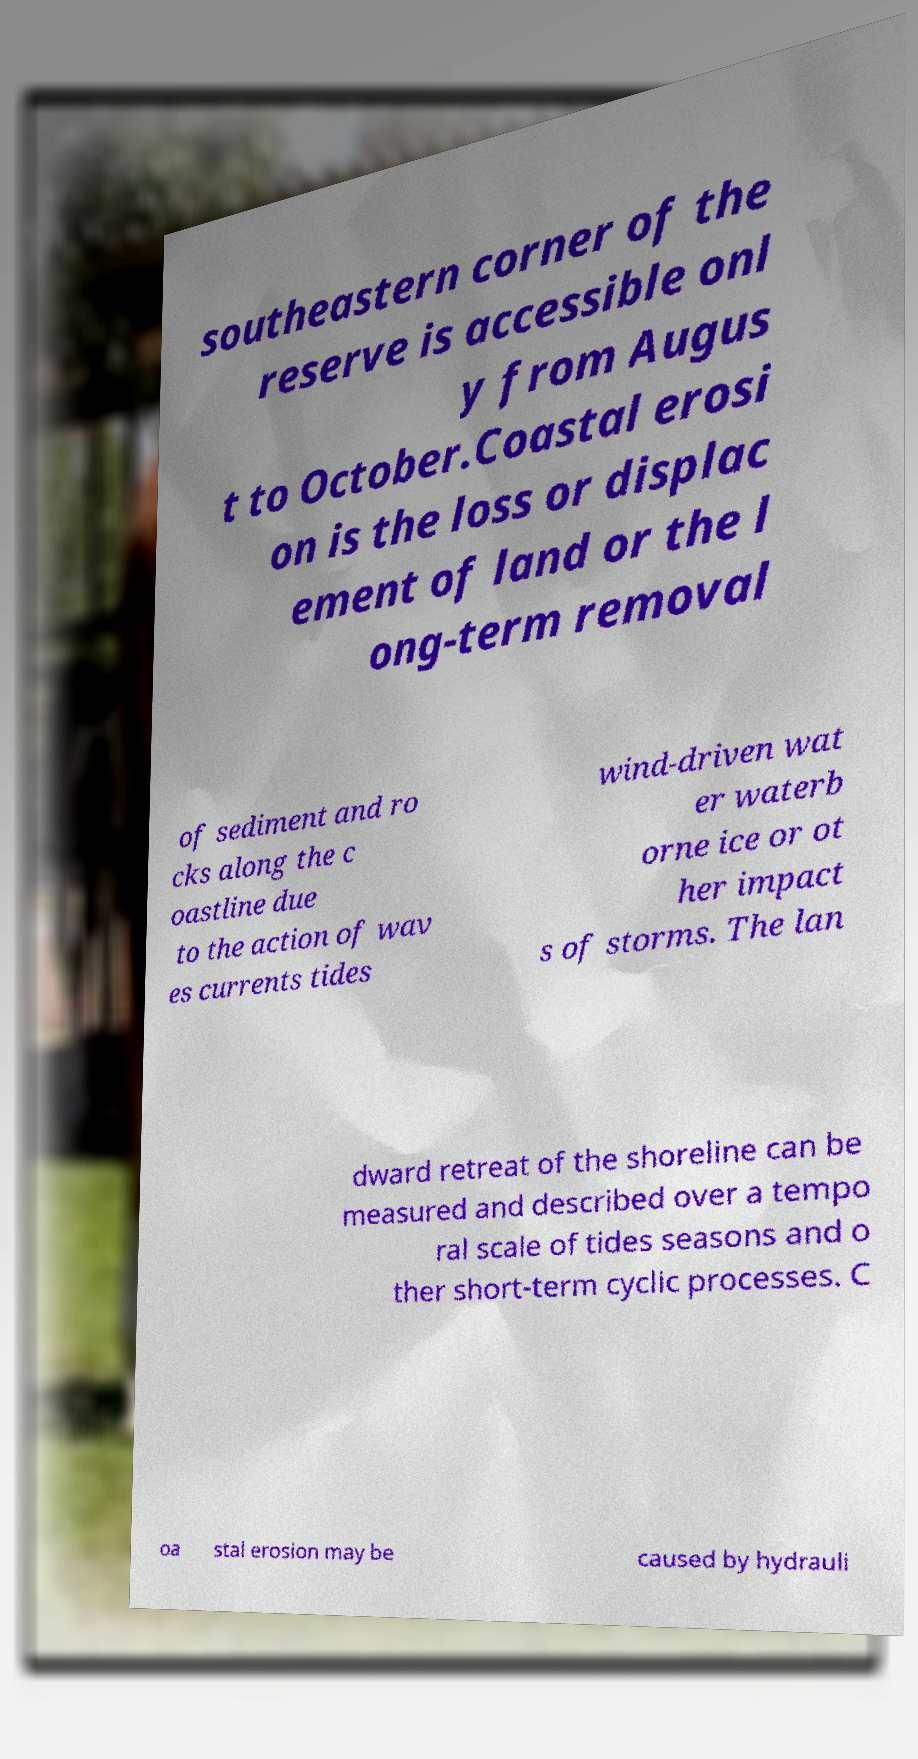I need the written content from this picture converted into text. Can you do that? southeastern corner of the reserve is accessible onl y from Augus t to October.Coastal erosi on is the loss or displac ement of land or the l ong-term removal of sediment and ro cks along the c oastline due to the action of wav es currents tides wind-driven wat er waterb orne ice or ot her impact s of storms. The lan dward retreat of the shoreline can be measured and described over a tempo ral scale of tides seasons and o ther short-term cyclic processes. C oa stal erosion may be caused by hydrauli 